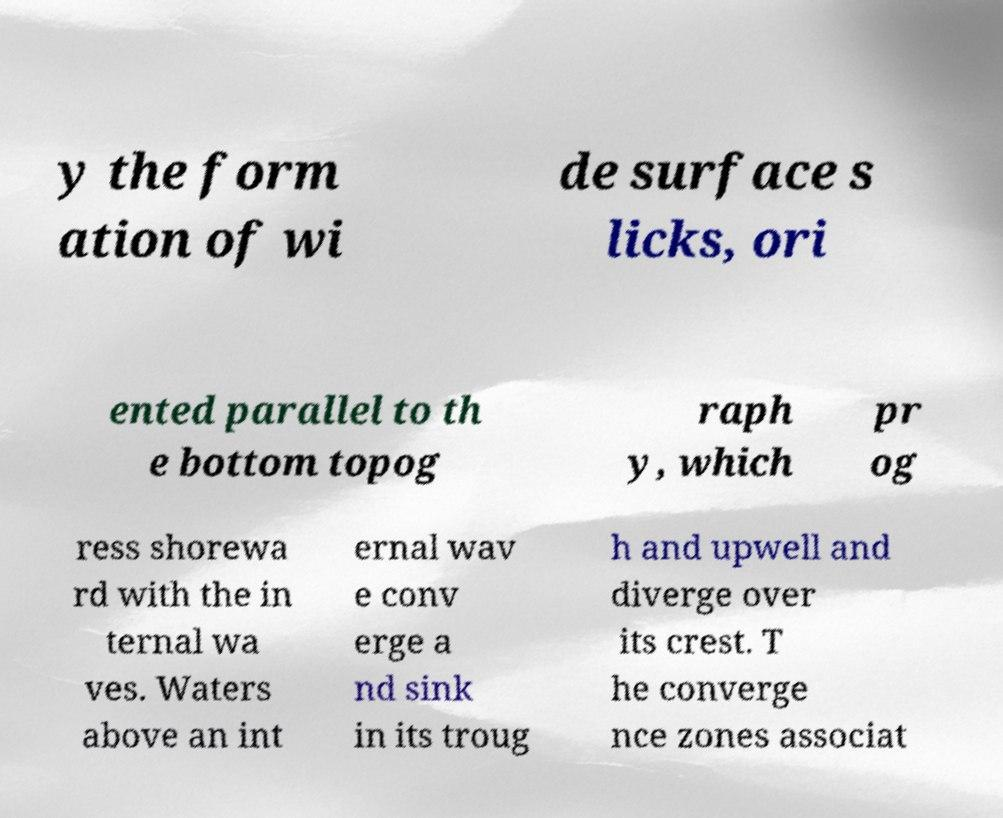What messages or text are displayed in this image? I need them in a readable, typed format. y the form ation of wi de surface s licks, ori ented parallel to th e bottom topog raph y, which pr og ress shorewa rd with the in ternal wa ves. Waters above an int ernal wav e conv erge a nd sink in its troug h and upwell and diverge over its crest. T he converge nce zones associat 